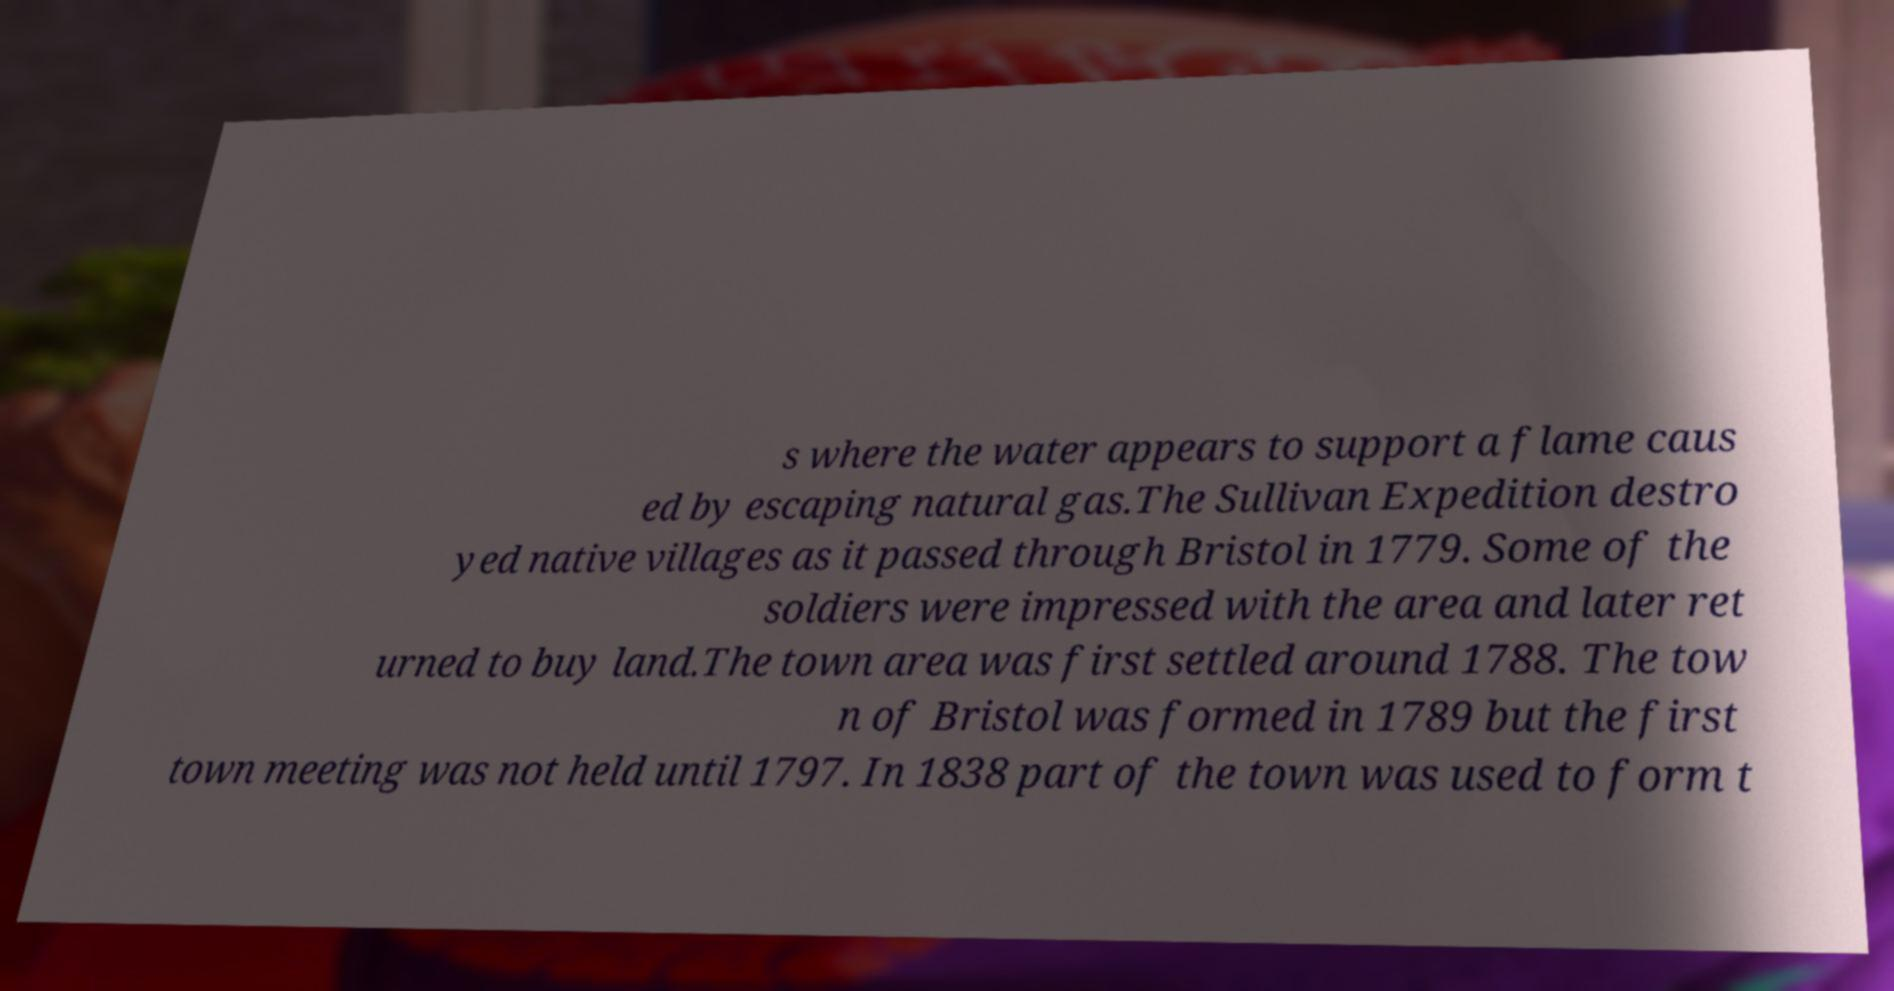There's text embedded in this image that I need extracted. Can you transcribe it verbatim? s where the water appears to support a flame caus ed by escaping natural gas.The Sullivan Expedition destro yed native villages as it passed through Bristol in 1779. Some of the soldiers were impressed with the area and later ret urned to buy land.The town area was first settled around 1788. The tow n of Bristol was formed in 1789 but the first town meeting was not held until 1797. In 1838 part of the town was used to form t 